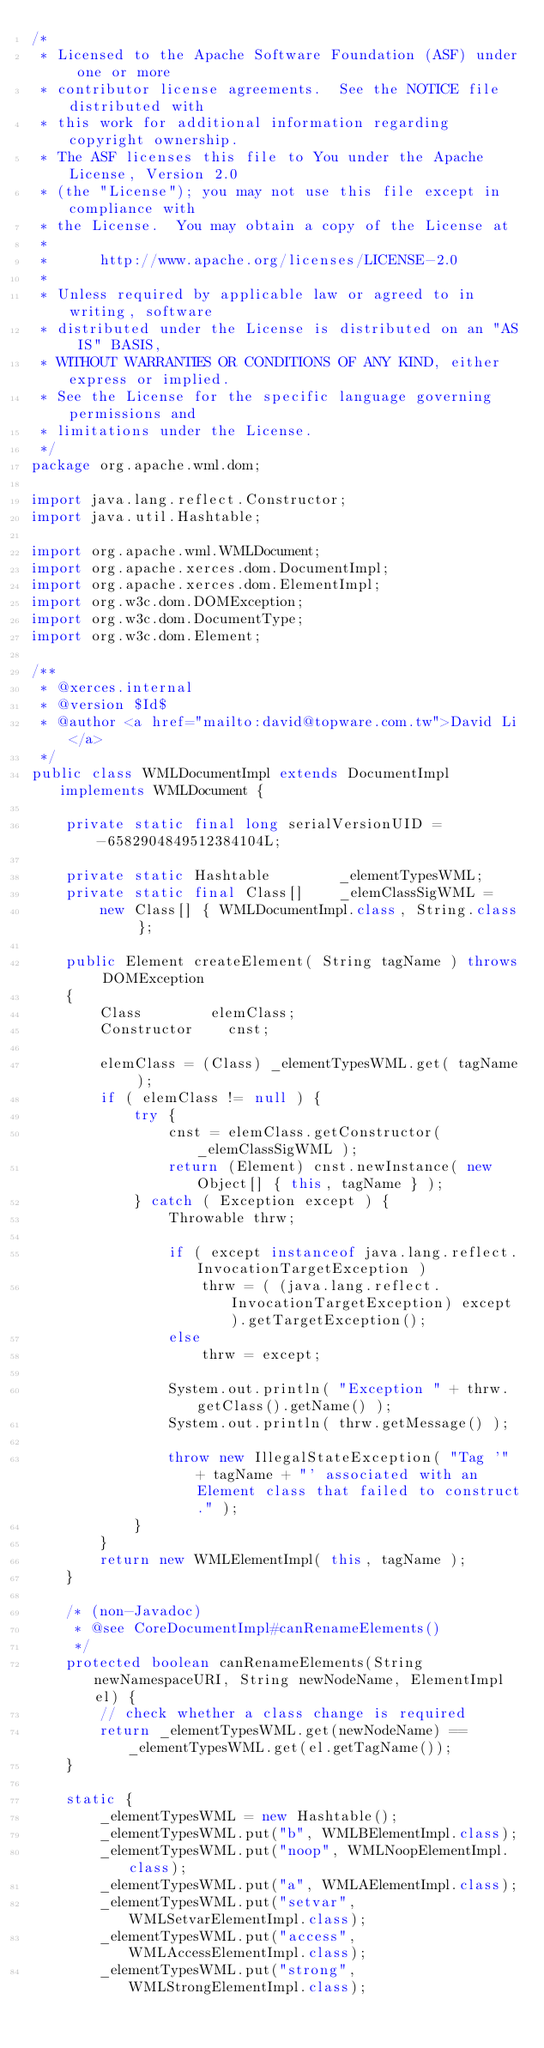Convert code to text. <code><loc_0><loc_0><loc_500><loc_500><_Java_>/*
 * Licensed to the Apache Software Foundation (ASF) under one or more
 * contributor license agreements.  See the NOTICE file distributed with
 * this work for additional information regarding copyright ownership.
 * The ASF licenses this file to You under the Apache License, Version 2.0
 * (the "License"); you may not use this file except in compliance with
 * the License.  You may obtain a copy of the License at
 * 
 *      http://www.apache.org/licenses/LICENSE-2.0
 * 
 * Unless required by applicable law or agreed to in writing, software
 * distributed under the License is distributed on an "AS IS" BASIS,
 * WITHOUT WARRANTIES OR CONDITIONS OF ANY KIND, either express or implied.
 * See the License for the specific language governing permissions and
 * limitations under the License.
 */
package org.apache.wml.dom;

import java.lang.reflect.Constructor;
import java.util.Hashtable;

import org.apache.wml.WMLDocument;
import org.apache.xerces.dom.DocumentImpl;
import org.apache.xerces.dom.ElementImpl;
import org.w3c.dom.DOMException;
import org.w3c.dom.DocumentType;
import org.w3c.dom.Element;

/**
 * @xerces.internal
 * @version $Id$
 * @author <a href="mailto:david@topware.com.tw">David Li</a>
 */
public class WMLDocumentImpl extends DocumentImpl implements WMLDocument {
    
    private static final long serialVersionUID = -6582904849512384104L;
    
    private static Hashtable        _elementTypesWML;
    private static final Class[]    _elemClassSigWML =
        new Class[] { WMLDocumentImpl.class, String.class };
    
    public Element createElement( String tagName ) throws DOMException
    {
        Class        elemClass;
        Constructor    cnst;
        
        elemClass = (Class) _elementTypesWML.get( tagName );
        if ( elemClass != null ) {
            try	{
                cnst = elemClass.getConstructor( _elemClassSigWML );
                return (Element) cnst.newInstance( new Object[] { this, tagName } );
            } catch ( Exception except ) {
                Throwable thrw;
                
                if ( except instanceof java.lang.reflect.InvocationTargetException )
                    thrw = ( (java.lang.reflect.InvocationTargetException) except ).getTargetException();
                else
                    thrw = except;
                
                System.out.println( "Exception " + thrw.getClass().getName() );
                System.out.println( thrw.getMessage() );
                
                throw new IllegalStateException( "Tag '" + tagName + "' associated with an Element class that failed to construct." );
            }
        }
        return new WMLElementImpl( this, tagName );
    }
    
    /* (non-Javadoc)
     * @see CoreDocumentImpl#canRenameElements()
     */
    protected boolean canRenameElements(String newNamespaceURI, String newNodeName, ElementImpl el) {
        // check whether a class change is required
        return _elementTypesWML.get(newNodeName) == _elementTypesWML.get(el.getTagName());
    }
    
    static {
        _elementTypesWML = new Hashtable();
        _elementTypesWML.put("b", WMLBElementImpl.class);
        _elementTypesWML.put("noop", WMLNoopElementImpl.class);
        _elementTypesWML.put("a", WMLAElementImpl.class);
        _elementTypesWML.put("setvar", WMLSetvarElementImpl.class);
        _elementTypesWML.put("access", WMLAccessElementImpl.class);
        _elementTypesWML.put("strong", WMLStrongElementImpl.class);</code> 